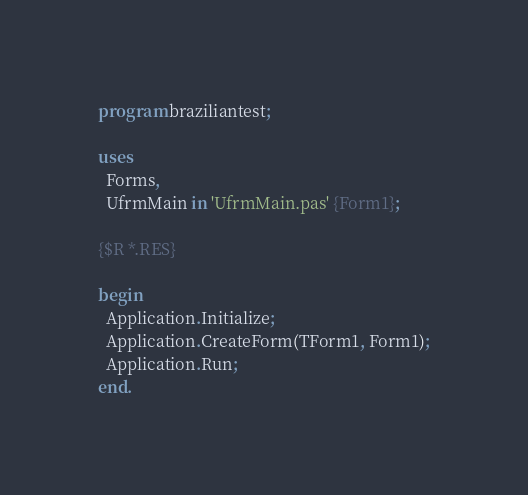Convert code to text. <code><loc_0><loc_0><loc_500><loc_500><_Pascal_>program braziliantest;

uses
  Forms,
  UfrmMain in 'UfrmMain.pas' {Form1};

{$R *.RES}

begin
  Application.Initialize;
  Application.CreateForm(TForm1, Form1);
  Application.Run;
end.
</code> 